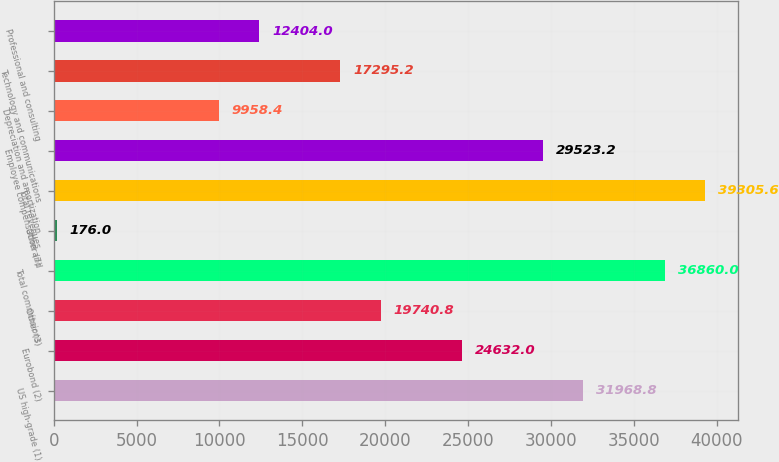Convert chart. <chart><loc_0><loc_0><loc_500><loc_500><bar_chart><fcel>US high-grade (1)<fcel>Eurobond (2)<fcel>Other (3)<fcel>Total commissions<fcel>Other (7)<fcel>Total revenues<fcel>Employee compensation and<fcel>Depreciation and amortization<fcel>Technology and communications<fcel>Professional and consulting<nl><fcel>31968.8<fcel>24632<fcel>19740.8<fcel>36860<fcel>176<fcel>39305.6<fcel>29523.2<fcel>9958.4<fcel>17295.2<fcel>12404<nl></chart> 